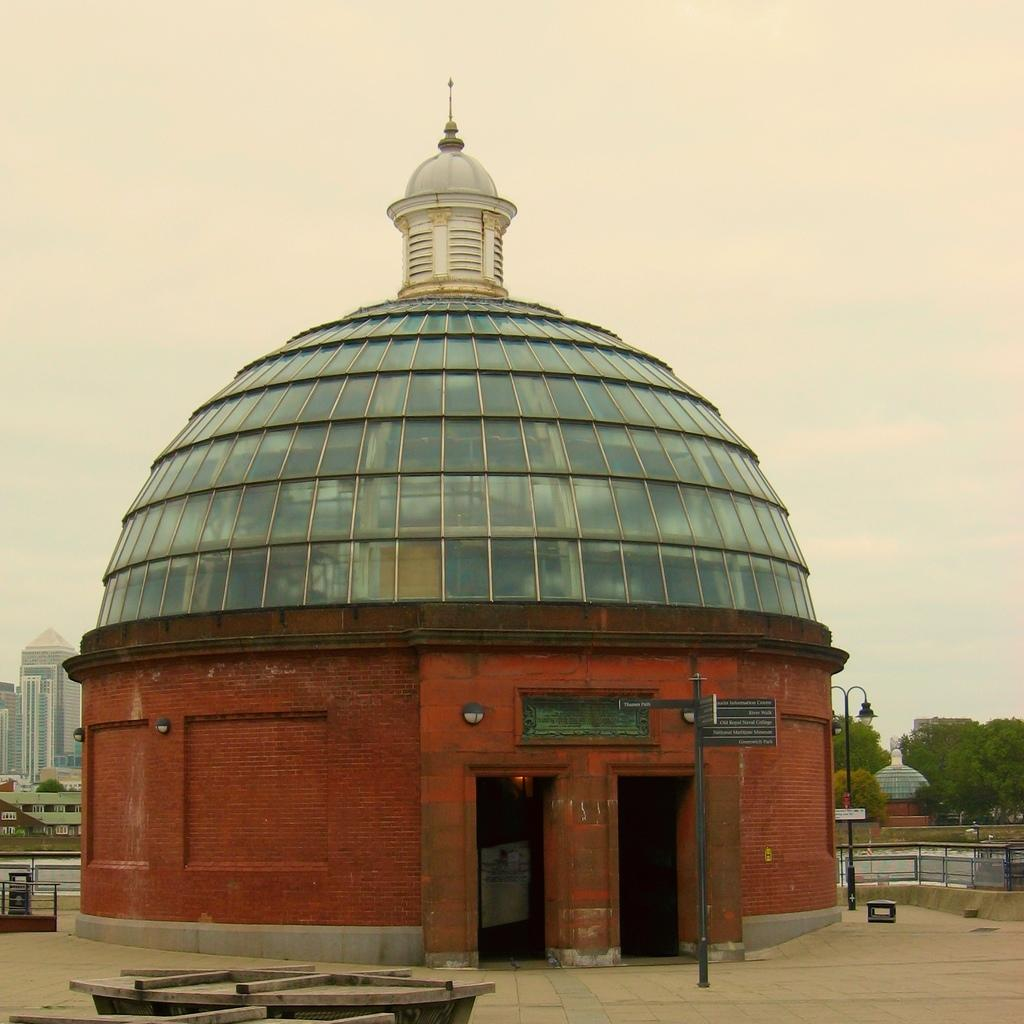What is the main structure in the image? There is a brick structure with glass in the center of the image. What can be seen in the background of the image? There are trees, buildings, and the sky visible in the background of the image. What is at the bottom of the image? There is a floor at the bottom of the image. What type of egg is being cooked on the floor in the image? There is no egg or cooking activity present in the image. What pet can be seen interacting with the brick structure in the image? There is no pet present in the image; it only features the brick structure, background elements, and the floor. 